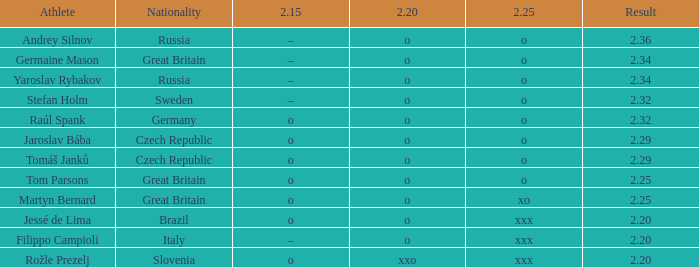Which german athlete possesses a Raúl Spank. Give me the full table as a dictionary. {'header': ['Athlete', 'Nationality', '2.15', '2.20', '2.25', 'Result'], 'rows': [['Andrey Silnov', 'Russia', '–', 'o', 'o', '2.36'], ['Germaine Mason', 'Great Britain', '–', 'o', 'o', '2.34'], ['Yaroslav Rybakov', 'Russia', '–', 'o', 'o', '2.34'], ['Stefan Holm', 'Sweden', '–', 'o', 'o', '2.32'], ['Raúl Spank', 'Germany', 'o', 'o', 'o', '2.32'], ['Jaroslav Bába', 'Czech Republic', 'o', 'o', 'o', '2.29'], ['Tomáš Janků', 'Czech Republic', 'o', 'o', 'o', '2.29'], ['Tom Parsons', 'Great Britain', 'o', 'o', 'o', '2.25'], ['Martyn Bernard', 'Great Britain', 'o', 'o', 'xo', '2.25'], ['Jessé de Lima', 'Brazil', 'o', 'o', 'xxx', '2.20'], ['Filippo Campioli', 'Italy', '–', 'o', 'xxx', '2.20'], ['Rožle Prezelj', 'Slovenia', 'o', 'xxo', 'xxx', '2.20']]} 